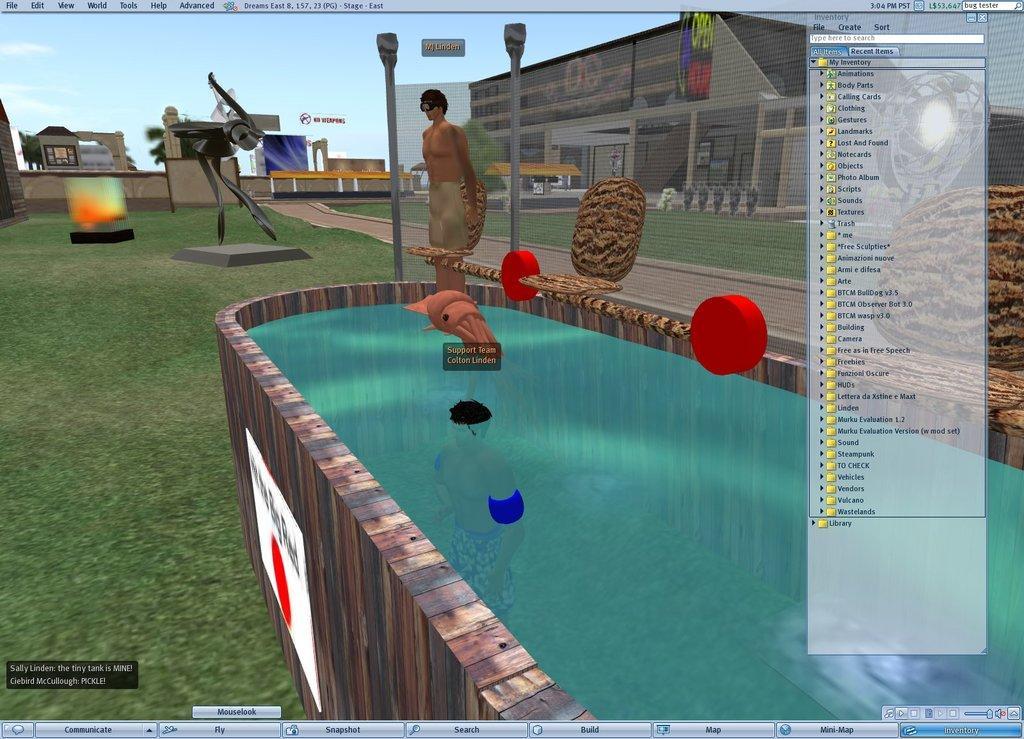Describe this image in one or two sentences. In this image we can see a monitor screen in which there is a person, a container with water, poles, grass, buildings and the sky. 